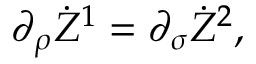Convert formula to latex. <formula><loc_0><loc_0><loc_500><loc_500>\partial _ { \rho } \dot { Z } ^ { 1 } = \partial _ { \sigma } \dot { Z } ^ { 2 } ,</formula> 